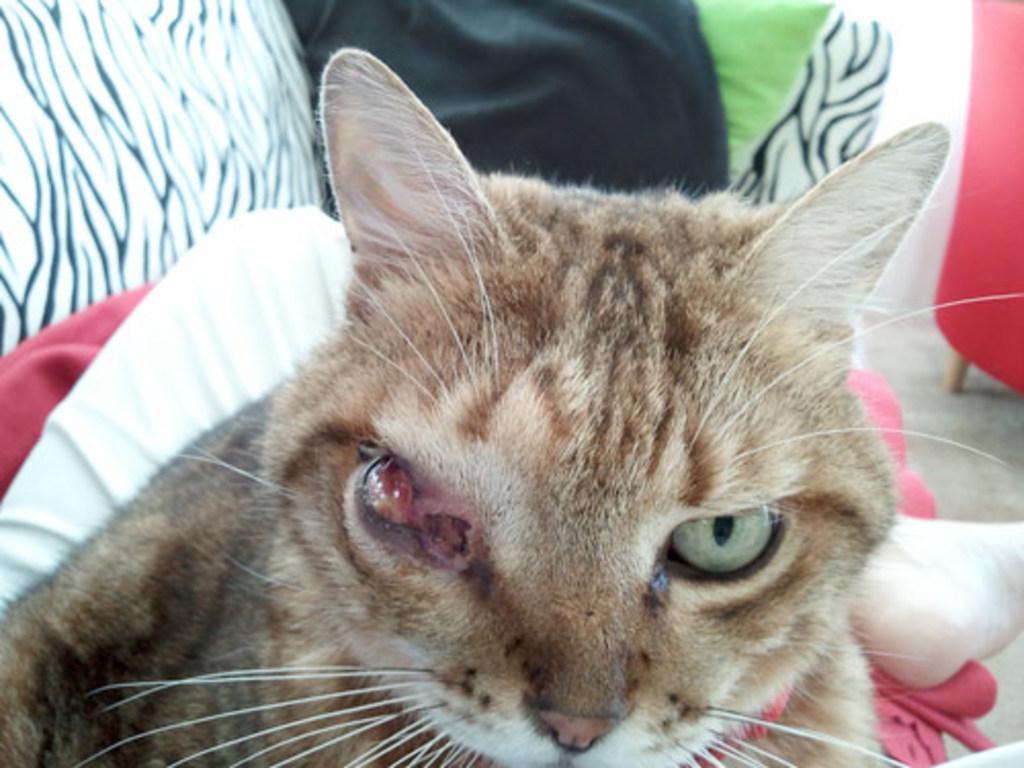How would you summarize this image in a sentence or two? In this image we can see a cat. 